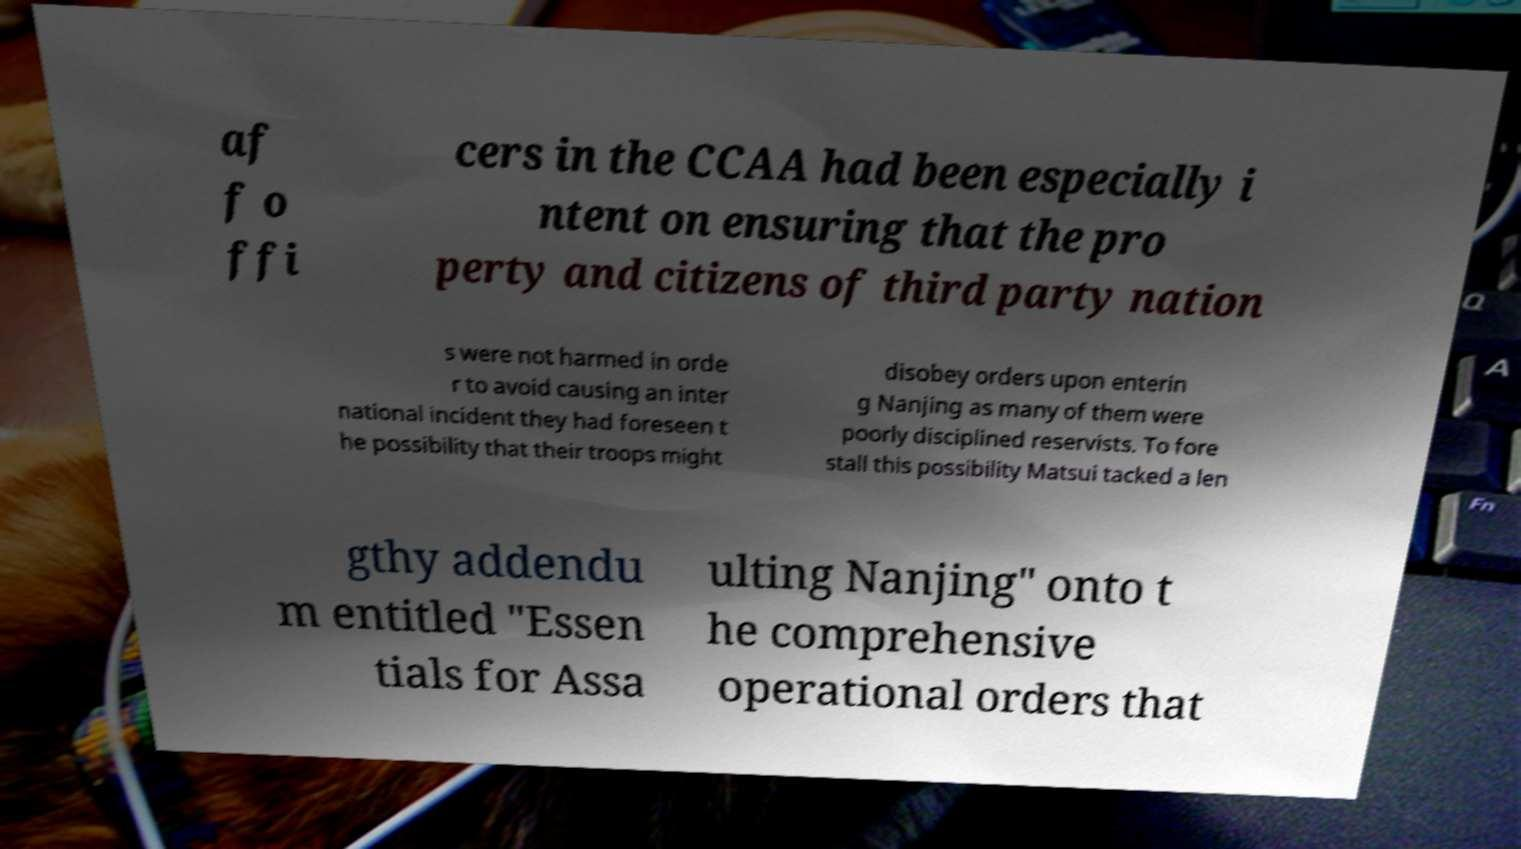Could you extract and type out the text from this image? af f o ffi cers in the CCAA had been especially i ntent on ensuring that the pro perty and citizens of third party nation s were not harmed in orde r to avoid causing an inter national incident they had foreseen t he possibility that their troops might disobey orders upon enterin g Nanjing as many of them were poorly disciplined reservists. To fore stall this possibility Matsui tacked a len gthy addendu m entitled "Essen tials for Assa ulting Nanjing" onto t he comprehensive operational orders that 